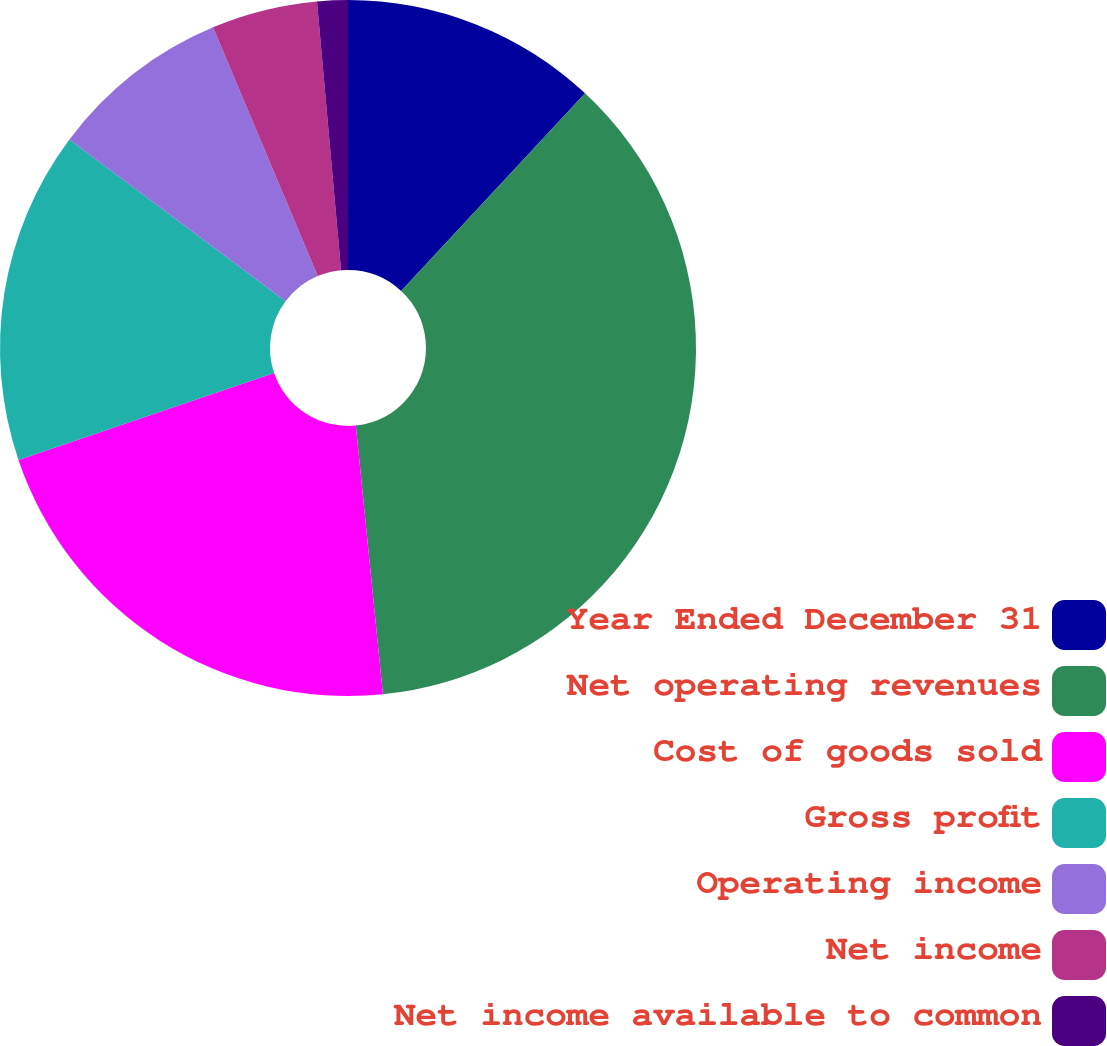<chart> <loc_0><loc_0><loc_500><loc_500><pie_chart><fcel>Year Ended December 31<fcel>Net operating revenues<fcel>Cost of goods sold<fcel>Gross profit<fcel>Operating income<fcel>Net income<fcel>Net income available to common<nl><fcel>11.93%<fcel>36.47%<fcel>21.39%<fcel>15.44%<fcel>8.43%<fcel>4.92%<fcel>1.42%<nl></chart> 